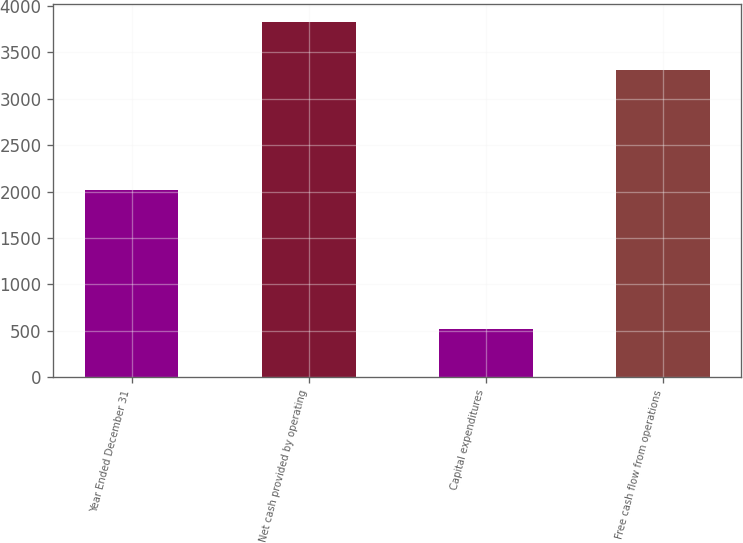Convert chart. <chart><loc_0><loc_0><loc_500><loc_500><bar_chart><fcel>Year Ended December 31<fcel>Net cash provided by operating<fcel>Capital expenditures<fcel>Free cash flow from operations<nl><fcel>2014<fcel>3828<fcel>521<fcel>3307<nl></chart> 